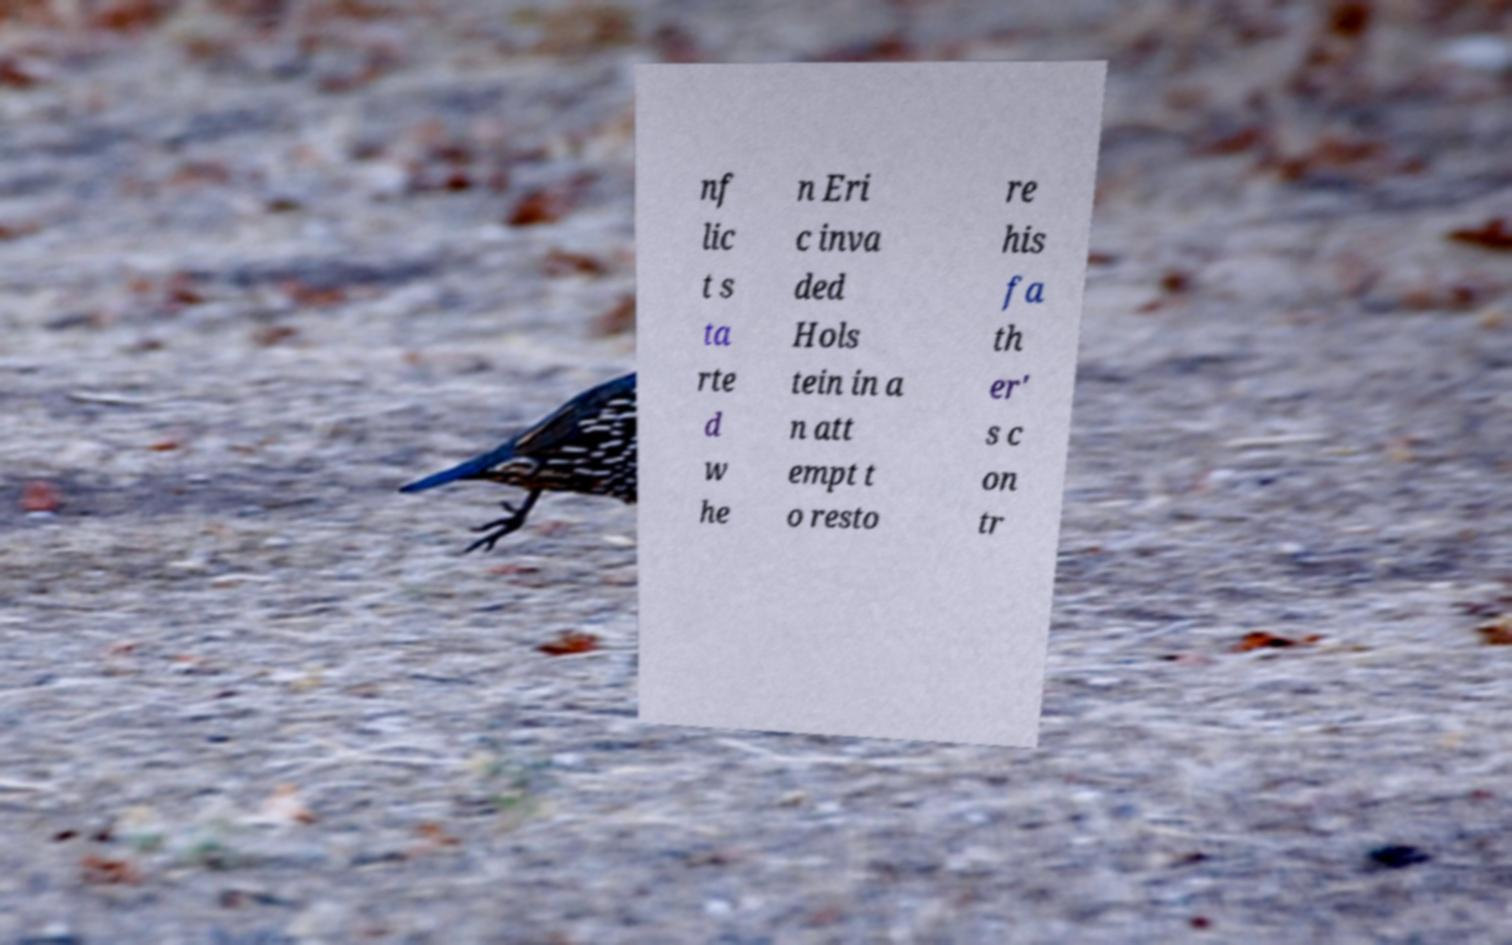Can you accurately transcribe the text from the provided image for me? nf lic t s ta rte d w he n Eri c inva ded Hols tein in a n att empt t o resto re his fa th er' s c on tr 